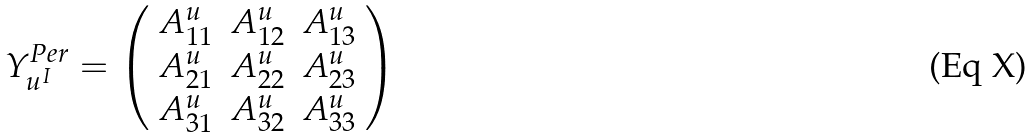<formula> <loc_0><loc_0><loc_500><loc_500>Y ^ { P e r } _ { u ^ { I } } = \left ( \begin{array} { c c c } A ^ { u } _ { 1 1 } & A ^ { u } _ { 1 2 } & A ^ { u } _ { 1 3 } \\ A ^ { u } _ { 2 1 } & A ^ { u } _ { 2 2 } & A ^ { u } _ { 2 3 } \\ A ^ { u } _ { 3 1 } & A ^ { u } _ { 3 2 } & A ^ { u } _ { 3 3 } \\ \end{array} \right )</formula> 